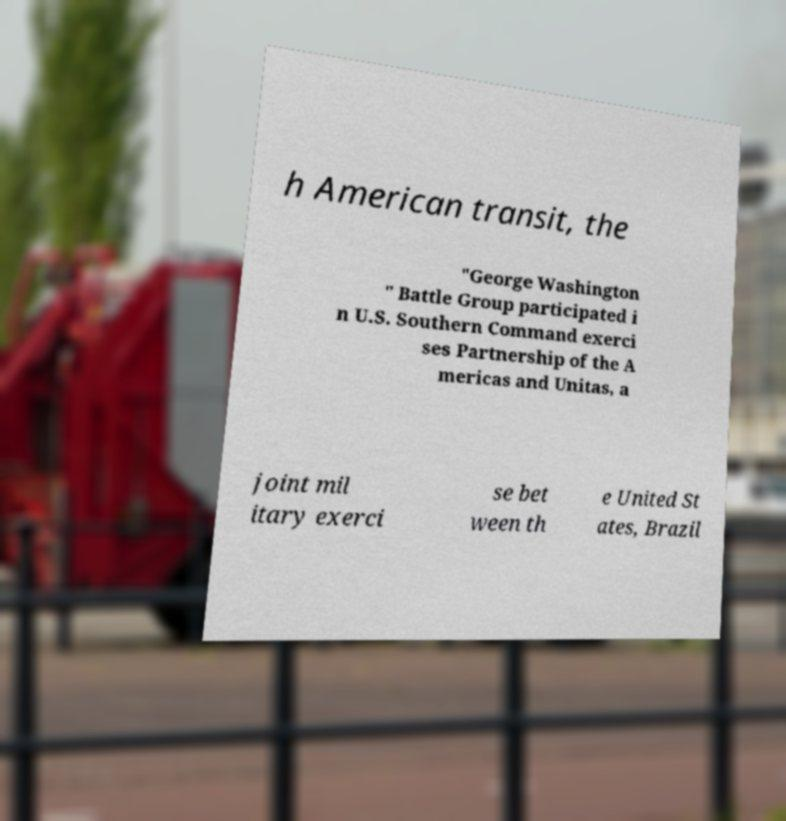Could you assist in decoding the text presented in this image and type it out clearly? h American transit, the "George Washington " Battle Group participated i n U.S. Southern Command exerci ses Partnership of the A mericas and Unitas, a joint mil itary exerci se bet ween th e United St ates, Brazil 